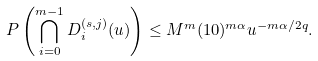Convert formula to latex. <formula><loc_0><loc_0><loc_500><loc_500>P \left ( \bigcap _ { i = 0 } ^ { m - 1 } D ^ { ( s , j ) } _ { i } ( u ) \right ) \leq M ^ { m } ( 1 0 ) ^ { m \alpha } u ^ { - m \alpha / 2 q } .</formula> 